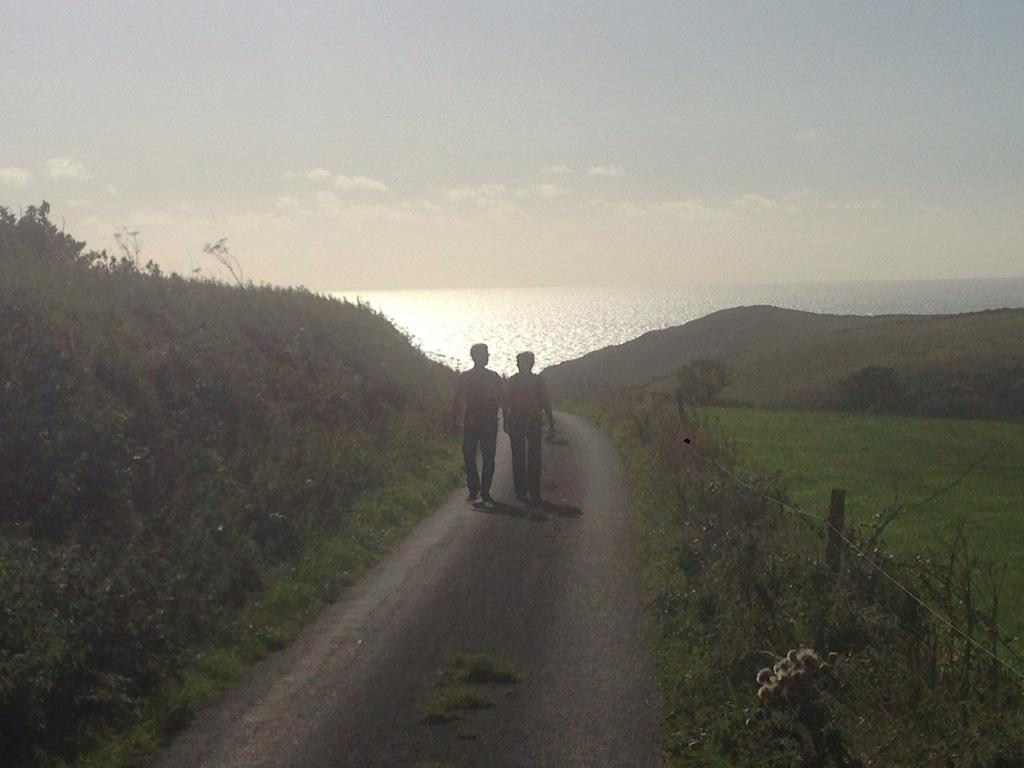How many people are present in the image? There are two people on the road in the image. What type of vegetation can be seen in the image? There is grass, plants, and trees visible in the image. What natural features can be seen in the image? There are mountains and water visible in the image. What is visible in the background of the image? The sky is visible in the background of the image, with clouds present. What time of day is it in the image, and what is the head of the mountain called? The time of day cannot be determined from the image, and there is no mention of a mountain's head. 